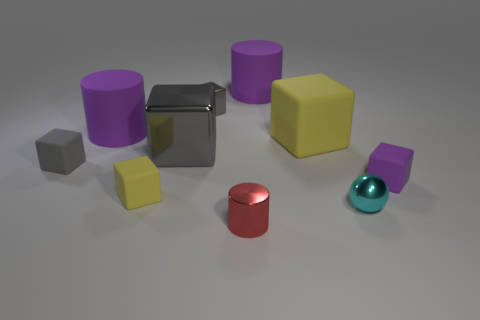What is the small purple thing made of?
Offer a very short reply. Rubber. What number of cylinders are gray shiny objects or red objects?
Give a very brief answer. 1. Is the small cylinder made of the same material as the tiny purple object?
Your response must be concise. No. The purple object that is the same shape as the big gray thing is what size?
Keep it short and to the point. Small. What is the cube that is to the right of the red shiny cylinder and to the left of the small cyan metallic object made of?
Your answer should be compact. Rubber. Is the number of purple objects that are in front of the small gray rubber thing the same as the number of red cylinders?
Your response must be concise. Yes. How many things are either cylinders that are behind the tiny yellow rubber cube or gray shiny things?
Offer a very short reply. 4. Is the color of the object to the right of the small metallic sphere the same as the small cylinder?
Make the answer very short. No. There is a matte cube in front of the small purple thing; what is its size?
Your answer should be compact. Small. There is a purple rubber thing that is behind the rubber cylinder left of the small yellow block; what is its shape?
Ensure brevity in your answer.  Cylinder. 